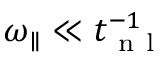Convert formula to latex. <formula><loc_0><loc_0><loc_500><loc_500>{ \omega _ { \| } } \ll t _ { n l } ^ { - 1 }</formula> 